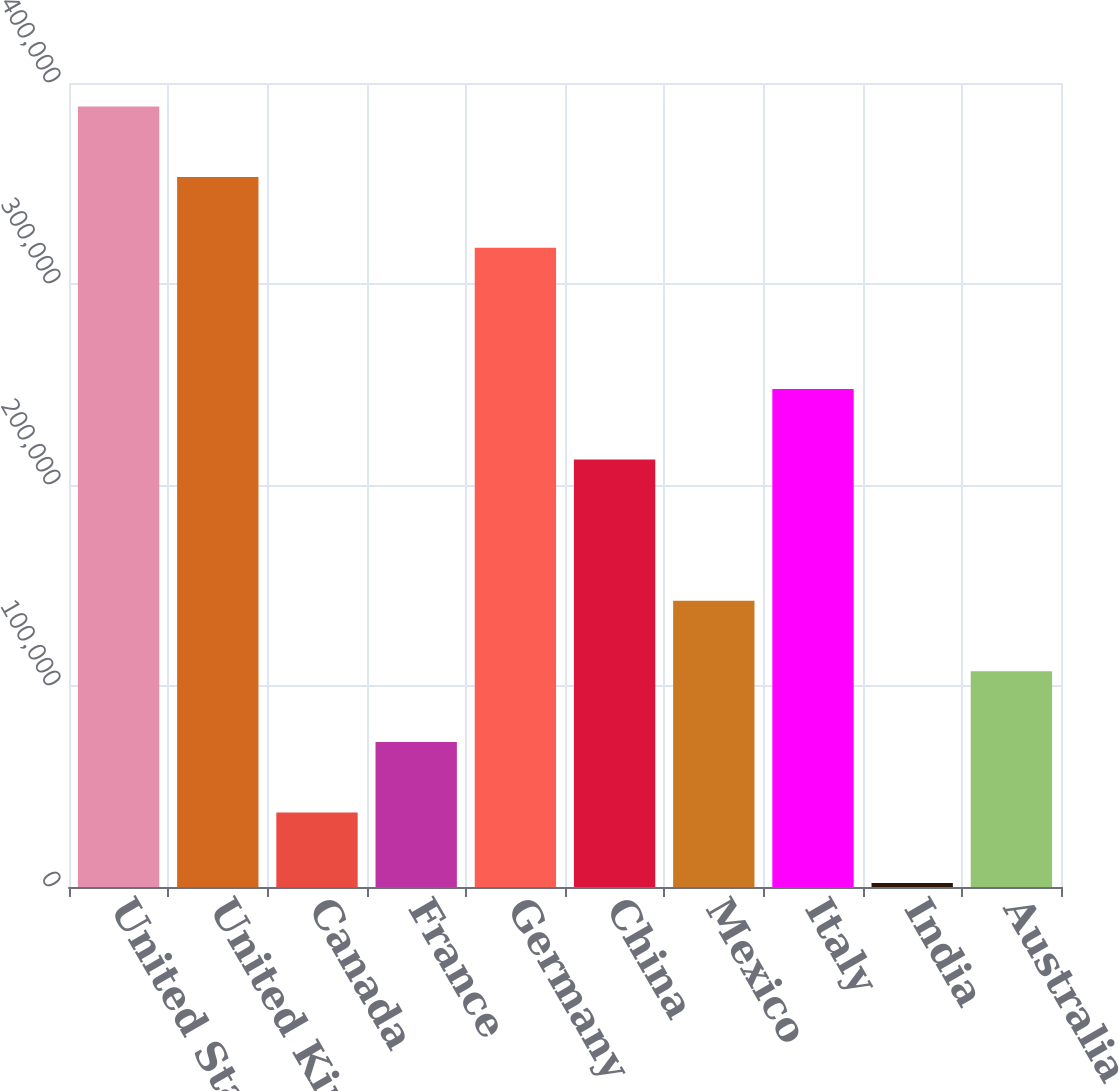Convert chart. <chart><loc_0><loc_0><loc_500><loc_500><bar_chart><fcel>United States<fcel>United Kingdom<fcel>Canada<fcel>France<fcel>Germany<fcel>China<fcel>Mexico<fcel>Italy<fcel>India<fcel>Australia<nl><fcel>388318<fcel>353193<fcel>37070.7<fcel>72195.4<fcel>318068<fcel>212694<fcel>142445<fcel>247819<fcel>1946<fcel>107320<nl></chart> 